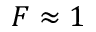<formula> <loc_0><loc_0><loc_500><loc_500>F \approx 1</formula> 